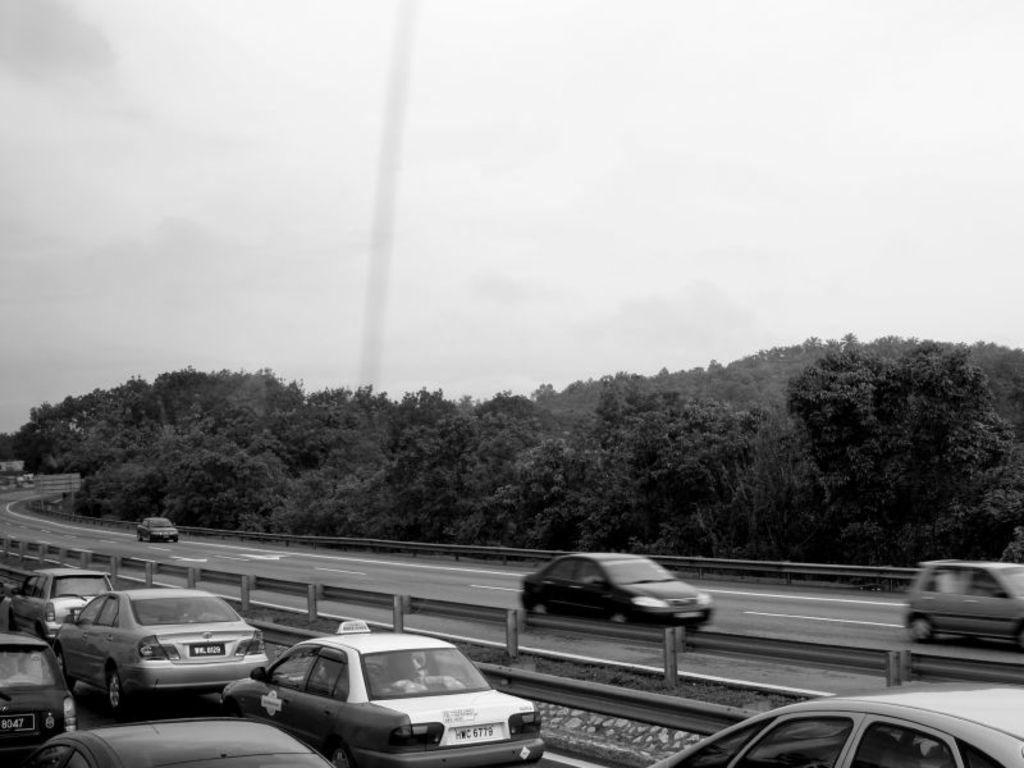What can be seen on the road in the image? There are cars on the road in the image. What type of vegetation is visible in the background of the image? There are trees in the background of the image. What part of the natural environment is visible in the image? The sky is visible in the background of the image. What type of liquid is being poured from the bat in the image? There is no bat or liquid present in the image; it features cars on the road and trees in the background. 